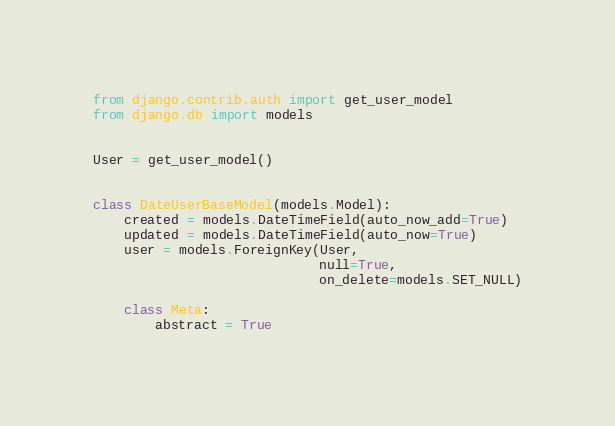<code> <loc_0><loc_0><loc_500><loc_500><_Python_>from django.contrib.auth import get_user_model
from django.db import models


User = get_user_model()


class DateUserBaseModel(models.Model):
    created = models.DateTimeField(auto_now_add=True)
    updated = models.DateTimeField(auto_now=True)
    user = models.ForeignKey(User,
                             null=True,
                             on_delete=models.SET_NULL)

    class Meta:
        abstract = True
</code> 